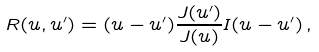Convert formula to latex. <formula><loc_0><loc_0><loc_500><loc_500>R ( u , u ^ { \prime } ) = ( u - u ^ { \prime } ) \frac { J ( u ^ { \prime } ) } { J ( u ) } I ( u - u ^ { \prime } ) \, ,</formula> 